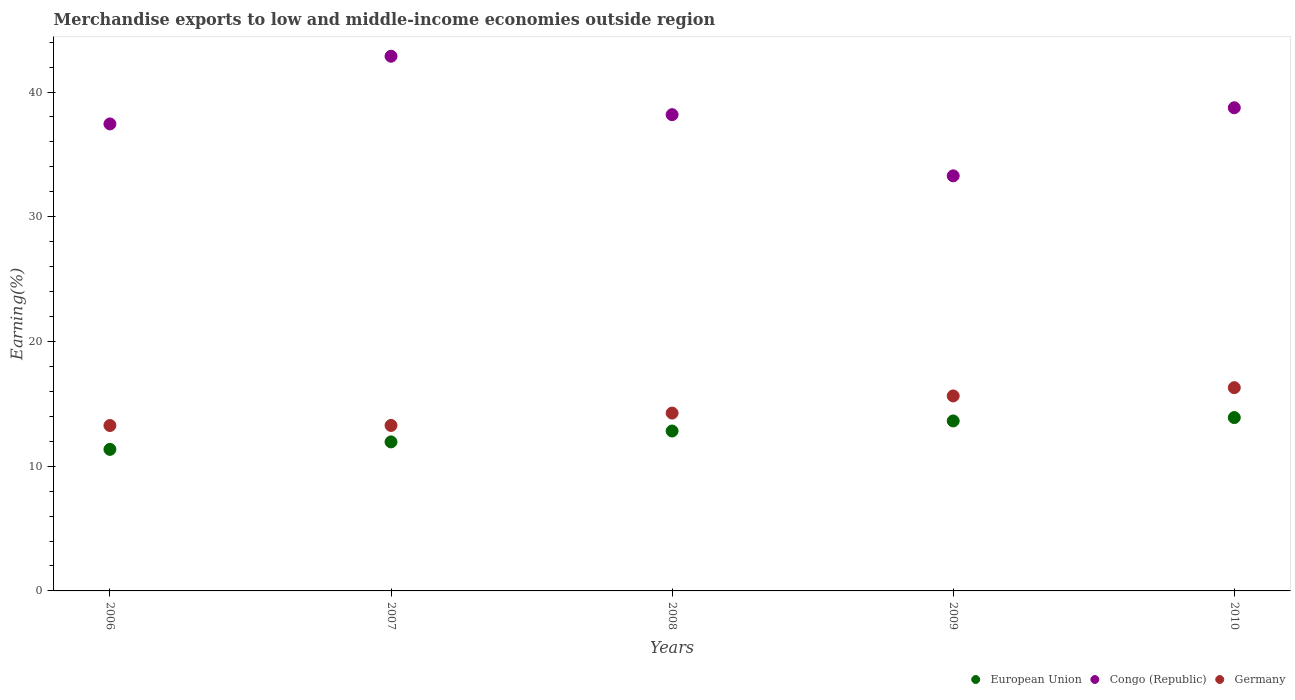How many different coloured dotlines are there?
Offer a terse response. 3. What is the percentage of amount earned from merchandise exports in Congo (Republic) in 2010?
Provide a short and direct response. 38.74. Across all years, what is the maximum percentage of amount earned from merchandise exports in Congo (Republic)?
Keep it short and to the point. 42.87. Across all years, what is the minimum percentage of amount earned from merchandise exports in Germany?
Keep it short and to the point. 13.26. In which year was the percentage of amount earned from merchandise exports in Germany maximum?
Give a very brief answer. 2010. What is the total percentage of amount earned from merchandise exports in Congo (Republic) in the graph?
Offer a very short reply. 190.53. What is the difference between the percentage of amount earned from merchandise exports in Germany in 2006 and that in 2007?
Provide a short and direct response. -0.01. What is the difference between the percentage of amount earned from merchandise exports in Germany in 2009 and the percentage of amount earned from merchandise exports in Congo (Republic) in 2008?
Make the answer very short. -22.55. What is the average percentage of amount earned from merchandise exports in Congo (Republic) per year?
Give a very brief answer. 38.11. In the year 2007, what is the difference between the percentage of amount earned from merchandise exports in Congo (Republic) and percentage of amount earned from merchandise exports in Germany?
Ensure brevity in your answer.  29.6. What is the ratio of the percentage of amount earned from merchandise exports in Congo (Republic) in 2008 to that in 2009?
Provide a short and direct response. 1.15. Is the percentage of amount earned from merchandise exports in European Union in 2007 less than that in 2008?
Ensure brevity in your answer.  Yes. What is the difference between the highest and the second highest percentage of amount earned from merchandise exports in Germany?
Your answer should be very brief. 0.66. What is the difference between the highest and the lowest percentage of amount earned from merchandise exports in European Union?
Keep it short and to the point. 2.55. Is the sum of the percentage of amount earned from merchandise exports in European Union in 2007 and 2009 greater than the maximum percentage of amount earned from merchandise exports in Germany across all years?
Ensure brevity in your answer.  Yes. Is the percentage of amount earned from merchandise exports in Congo (Republic) strictly greater than the percentage of amount earned from merchandise exports in European Union over the years?
Offer a terse response. Yes. How many dotlines are there?
Provide a succinct answer. 3. What is the difference between two consecutive major ticks on the Y-axis?
Make the answer very short. 10. Are the values on the major ticks of Y-axis written in scientific E-notation?
Make the answer very short. No. Where does the legend appear in the graph?
Keep it short and to the point. Bottom right. How are the legend labels stacked?
Keep it short and to the point. Horizontal. What is the title of the graph?
Your answer should be compact. Merchandise exports to low and middle-income economies outside region. What is the label or title of the Y-axis?
Your response must be concise. Earning(%). What is the Earning(%) in European Union in 2006?
Offer a very short reply. 11.35. What is the Earning(%) in Congo (Republic) in 2006?
Make the answer very short. 37.44. What is the Earning(%) of Germany in 2006?
Make the answer very short. 13.26. What is the Earning(%) in European Union in 2007?
Your answer should be compact. 11.95. What is the Earning(%) in Congo (Republic) in 2007?
Make the answer very short. 42.87. What is the Earning(%) in Germany in 2007?
Ensure brevity in your answer.  13.27. What is the Earning(%) of European Union in 2008?
Give a very brief answer. 12.82. What is the Earning(%) in Congo (Republic) in 2008?
Provide a short and direct response. 38.19. What is the Earning(%) of Germany in 2008?
Provide a short and direct response. 14.26. What is the Earning(%) of European Union in 2009?
Your answer should be very brief. 13.63. What is the Earning(%) in Congo (Republic) in 2009?
Ensure brevity in your answer.  33.28. What is the Earning(%) in Germany in 2009?
Keep it short and to the point. 15.63. What is the Earning(%) in European Union in 2010?
Keep it short and to the point. 13.9. What is the Earning(%) of Congo (Republic) in 2010?
Your answer should be very brief. 38.74. What is the Earning(%) in Germany in 2010?
Your answer should be very brief. 16.3. Across all years, what is the maximum Earning(%) of European Union?
Your answer should be very brief. 13.9. Across all years, what is the maximum Earning(%) of Congo (Republic)?
Keep it short and to the point. 42.87. Across all years, what is the maximum Earning(%) in Germany?
Your answer should be compact. 16.3. Across all years, what is the minimum Earning(%) in European Union?
Provide a succinct answer. 11.35. Across all years, what is the minimum Earning(%) in Congo (Republic)?
Your answer should be compact. 33.28. Across all years, what is the minimum Earning(%) of Germany?
Offer a very short reply. 13.26. What is the total Earning(%) in European Union in the graph?
Keep it short and to the point. 63.65. What is the total Earning(%) in Congo (Republic) in the graph?
Give a very brief answer. 190.53. What is the total Earning(%) of Germany in the graph?
Make the answer very short. 72.72. What is the difference between the Earning(%) of European Union in 2006 and that in 2007?
Ensure brevity in your answer.  -0.6. What is the difference between the Earning(%) of Congo (Republic) in 2006 and that in 2007?
Make the answer very short. -5.43. What is the difference between the Earning(%) in Germany in 2006 and that in 2007?
Your answer should be compact. -0.01. What is the difference between the Earning(%) of European Union in 2006 and that in 2008?
Keep it short and to the point. -1.47. What is the difference between the Earning(%) of Congo (Republic) in 2006 and that in 2008?
Offer a very short reply. -0.74. What is the difference between the Earning(%) of Germany in 2006 and that in 2008?
Offer a very short reply. -1. What is the difference between the Earning(%) of European Union in 2006 and that in 2009?
Your response must be concise. -2.28. What is the difference between the Earning(%) in Congo (Republic) in 2006 and that in 2009?
Your response must be concise. 4.16. What is the difference between the Earning(%) of Germany in 2006 and that in 2009?
Keep it short and to the point. -2.37. What is the difference between the Earning(%) in European Union in 2006 and that in 2010?
Your response must be concise. -2.55. What is the difference between the Earning(%) in Congo (Republic) in 2006 and that in 2010?
Make the answer very short. -1.3. What is the difference between the Earning(%) in Germany in 2006 and that in 2010?
Make the answer very short. -3.04. What is the difference between the Earning(%) in European Union in 2007 and that in 2008?
Provide a succinct answer. -0.87. What is the difference between the Earning(%) of Congo (Republic) in 2007 and that in 2008?
Provide a succinct answer. 4.69. What is the difference between the Earning(%) of Germany in 2007 and that in 2008?
Make the answer very short. -0.99. What is the difference between the Earning(%) in European Union in 2007 and that in 2009?
Your response must be concise. -1.68. What is the difference between the Earning(%) of Congo (Republic) in 2007 and that in 2009?
Provide a short and direct response. 9.59. What is the difference between the Earning(%) in Germany in 2007 and that in 2009?
Provide a short and direct response. -2.37. What is the difference between the Earning(%) of European Union in 2007 and that in 2010?
Make the answer very short. -1.95. What is the difference between the Earning(%) in Congo (Republic) in 2007 and that in 2010?
Provide a short and direct response. 4.13. What is the difference between the Earning(%) of Germany in 2007 and that in 2010?
Provide a succinct answer. -3.03. What is the difference between the Earning(%) of European Union in 2008 and that in 2009?
Offer a very short reply. -0.81. What is the difference between the Earning(%) of Congo (Republic) in 2008 and that in 2009?
Your answer should be compact. 4.9. What is the difference between the Earning(%) in Germany in 2008 and that in 2009?
Offer a very short reply. -1.37. What is the difference between the Earning(%) of European Union in 2008 and that in 2010?
Provide a short and direct response. -1.08. What is the difference between the Earning(%) of Congo (Republic) in 2008 and that in 2010?
Your response must be concise. -0.55. What is the difference between the Earning(%) in Germany in 2008 and that in 2010?
Your response must be concise. -2.04. What is the difference between the Earning(%) of European Union in 2009 and that in 2010?
Give a very brief answer. -0.27. What is the difference between the Earning(%) of Congo (Republic) in 2009 and that in 2010?
Give a very brief answer. -5.46. What is the difference between the Earning(%) in Germany in 2009 and that in 2010?
Your answer should be compact. -0.66. What is the difference between the Earning(%) of European Union in 2006 and the Earning(%) of Congo (Republic) in 2007?
Ensure brevity in your answer.  -31.52. What is the difference between the Earning(%) in European Union in 2006 and the Earning(%) in Germany in 2007?
Offer a terse response. -1.92. What is the difference between the Earning(%) of Congo (Republic) in 2006 and the Earning(%) of Germany in 2007?
Make the answer very short. 24.18. What is the difference between the Earning(%) of European Union in 2006 and the Earning(%) of Congo (Republic) in 2008?
Provide a succinct answer. -26.84. What is the difference between the Earning(%) of European Union in 2006 and the Earning(%) of Germany in 2008?
Provide a succinct answer. -2.91. What is the difference between the Earning(%) in Congo (Republic) in 2006 and the Earning(%) in Germany in 2008?
Make the answer very short. 23.18. What is the difference between the Earning(%) in European Union in 2006 and the Earning(%) in Congo (Republic) in 2009?
Offer a terse response. -21.93. What is the difference between the Earning(%) of European Union in 2006 and the Earning(%) of Germany in 2009?
Keep it short and to the point. -4.29. What is the difference between the Earning(%) of Congo (Republic) in 2006 and the Earning(%) of Germany in 2009?
Provide a short and direct response. 21.81. What is the difference between the Earning(%) of European Union in 2006 and the Earning(%) of Congo (Republic) in 2010?
Keep it short and to the point. -27.39. What is the difference between the Earning(%) in European Union in 2006 and the Earning(%) in Germany in 2010?
Ensure brevity in your answer.  -4.95. What is the difference between the Earning(%) of Congo (Republic) in 2006 and the Earning(%) of Germany in 2010?
Ensure brevity in your answer.  21.15. What is the difference between the Earning(%) in European Union in 2007 and the Earning(%) in Congo (Republic) in 2008?
Provide a succinct answer. -26.24. What is the difference between the Earning(%) of European Union in 2007 and the Earning(%) of Germany in 2008?
Offer a terse response. -2.31. What is the difference between the Earning(%) of Congo (Republic) in 2007 and the Earning(%) of Germany in 2008?
Offer a terse response. 28.61. What is the difference between the Earning(%) in European Union in 2007 and the Earning(%) in Congo (Republic) in 2009?
Offer a terse response. -21.33. What is the difference between the Earning(%) of European Union in 2007 and the Earning(%) of Germany in 2009?
Provide a succinct answer. -3.69. What is the difference between the Earning(%) of Congo (Republic) in 2007 and the Earning(%) of Germany in 2009?
Provide a succinct answer. 27.24. What is the difference between the Earning(%) of European Union in 2007 and the Earning(%) of Congo (Republic) in 2010?
Keep it short and to the point. -26.79. What is the difference between the Earning(%) of European Union in 2007 and the Earning(%) of Germany in 2010?
Ensure brevity in your answer.  -4.35. What is the difference between the Earning(%) in Congo (Republic) in 2007 and the Earning(%) in Germany in 2010?
Your response must be concise. 26.57. What is the difference between the Earning(%) of European Union in 2008 and the Earning(%) of Congo (Republic) in 2009?
Offer a very short reply. -20.46. What is the difference between the Earning(%) in European Union in 2008 and the Earning(%) in Germany in 2009?
Your answer should be very brief. -2.81. What is the difference between the Earning(%) of Congo (Republic) in 2008 and the Earning(%) of Germany in 2009?
Offer a terse response. 22.55. What is the difference between the Earning(%) of European Union in 2008 and the Earning(%) of Congo (Republic) in 2010?
Offer a terse response. -25.92. What is the difference between the Earning(%) in European Union in 2008 and the Earning(%) in Germany in 2010?
Give a very brief answer. -3.48. What is the difference between the Earning(%) of Congo (Republic) in 2008 and the Earning(%) of Germany in 2010?
Provide a succinct answer. 21.89. What is the difference between the Earning(%) of European Union in 2009 and the Earning(%) of Congo (Republic) in 2010?
Your answer should be very brief. -25.11. What is the difference between the Earning(%) of European Union in 2009 and the Earning(%) of Germany in 2010?
Your answer should be very brief. -2.67. What is the difference between the Earning(%) of Congo (Republic) in 2009 and the Earning(%) of Germany in 2010?
Offer a very short reply. 16.98. What is the average Earning(%) in European Union per year?
Provide a short and direct response. 12.73. What is the average Earning(%) in Congo (Republic) per year?
Ensure brevity in your answer.  38.11. What is the average Earning(%) of Germany per year?
Make the answer very short. 14.54. In the year 2006, what is the difference between the Earning(%) of European Union and Earning(%) of Congo (Republic)?
Offer a terse response. -26.09. In the year 2006, what is the difference between the Earning(%) in European Union and Earning(%) in Germany?
Give a very brief answer. -1.91. In the year 2006, what is the difference between the Earning(%) of Congo (Republic) and Earning(%) of Germany?
Your response must be concise. 24.18. In the year 2007, what is the difference between the Earning(%) in European Union and Earning(%) in Congo (Republic)?
Ensure brevity in your answer.  -30.92. In the year 2007, what is the difference between the Earning(%) of European Union and Earning(%) of Germany?
Offer a very short reply. -1.32. In the year 2007, what is the difference between the Earning(%) of Congo (Republic) and Earning(%) of Germany?
Your answer should be compact. 29.6. In the year 2008, what is the difference between the Earning(%) of European Union and Earning(%) of Congo (Republic)?
Give a very brief answer. -25.37. In the year 2008, what is the difference between the Earning(%) of European Union and Earning(%) of Germany?
Your answer should be very brief. -1.44. In the year 2008, what is the difference between the Earning(%) in Congo (Republic) and Earning(%) in Germany?
Your response must be concise. 23.93. In the year 2009, what is the difference between the Earning(%) of European Union and Earning(%) of Congo (Republic)?
Make the answer very short. -19.65. In the year 2009, what is the difference between the Earning(%) in European Union and Earning(%) in Germany?
Your answer should be very brief. -2.01. In the year 2009, what is the difference between the Earning(%) of Congo (Republic) and Earning(%) of Germany?
Give a very brief answer. 17.65. In the year 2010, what is the difference between the Earning(%) in European Union and Earning(%) in Congo (Republic)?
Give a very brief answer. -24.84. In the year 2010, what is the difference between the Earning(%) in European Union and Earning(%) in Germany?
Offer a terse response. -2.4. In the year 2010, what is the difference between the Earning(%) of Congo (Republic) and Earning(%) of Germany?
Provide a succinct answer. 22.44. What is the ratio of the Earning(%) in European Union in 2006 to that in 2007?
Your answer should be compact. 0.95. What is the ratio of the Earning(%) of Congo (Republic) in 2006 to that in 2007?
Your answer should be very brief. 0.87. What is the ratio of the Earning(%) in Germany in 2006 to that in 2007?
Make the answer very short. 1. What is the ratio of the Earning(%) in European Union in 2006 to that in 2008?
Ensure brevity in your answer.  0.89. What is the ratio of the Earning(%) in Congo (Republic) in 2006 to that in 2008?
Your response must be concise. 0.98. What is the ratio of the Earning(%) in European Union in 2006 to that in 2009?
Make the answer very short. 0.83. What is the ratio of the Earning(%) in Congo (Republic) in 2006 to that in 2009?
Your response must be concise. 1.13. What is the ratio of the Earning(%) in Germany in 2006 to that in 2009?
Offer a very short reply. 0.85. What is the ratio of the Earning(%) in European Union in 2006 to that in 2010?
Offer a very short reply. 0.82. What is the ratio of the Earning(%) in Congo (Republic) in 2006 to that in 2010?
Provide a short and direct response. 0.97. What is the ratio of the Earning(%) in Germany in 2006 to that in 2010?
Your answer should be very brief. 0.81. What is the ratio of the Earning(%) in European Union in 2007 to that in 2008?
Provide a succinct answer. 0.93. What is the ratio of the Earning(%) in Congo (Republic) in 2007 to that in 2008?
Provide a short and direct response. 1.12. What is the ratio of the Earning(%) of Germany in 2007 to that in 2008?
Offer a terse response. 0.93. What is the ratio of the Earning(%) in European Union in 2007 to that in 2009?
Your response must be concise. 0.88. What is the ratio of the Earning(%) of Congo (Republic) in 2007 to that in 2009?
Make the answer very short. 1.29. What is the ratio of the Earning(%) in Germany in 2007 to that in 2009?
Keep it short and to the point. 0.85. What is the ratio of the Earning(%) of European Union in 2007 to that in 2010?
Make the answer very short. 0.86. What is the ratio of the Earning(%) of Congo (Republic) in 2007 to that in 2010?
Your response must be concise. 1.11. What is the ratio of the Earning(%) of Germany in 2007 to that in 2010?
Keep it short and to the point. 0.81. What is the ratio of the Earning(%) in European Union in 2008 to that in 2009?
Provide a succinct answer. 0.94. What is the ratio of the Earning(%) in Congo (Republic) in 2008 to that in 2009?
Your answer should be very brief. 1.15. What is the ratio of the Earning(%) in Germany in 2008 to that in 2009?
Keep it short and to the point. 0.91. What is the ratio of the Earning(%) in European Union in 2008 to that in 2010?
Offer a very short reply. 0.92. What is the ratio of the Earning(%) in Congo (Republic) in 2008 to that in 2010?
Keep it short and to the point. 0.99. What is the ratio of the Earning(%) in European Union in 2009 to that in 2010?
Give a very brief answer. 0.98. What is the ratio of the Earning(%) of Congo (Republic) in 2009 to that in 2010?
Offer a very short reply. 0.86. What is the ratio of the Earning(%) of Germany in 2009 to that in 2010?
Give a very brief answer. 0.96. What is the difference between the highest and the second highest Earning(%) in European Union?
Your answer should be compact. 0.27. What is the difference between the highest and the second highest Earning(%) in Congo (Republic)?
Offer a terse response. 4.13. What is the difference between the highest and the second highest Earning(%) of Germany?
Your response must be concise. 0.66. What is the difference between the highest and the lowest Earning(%) in European Union?
Your answer should be very brief. 2.55. What is the difference between the highest and the lowest Earning(%) in Congo (Republic)?
Provide a short and direct response. 9.59. What is the difference between the highest and the lowest Earning(%) in Germany?
Give a very brief answer. 3.04. 